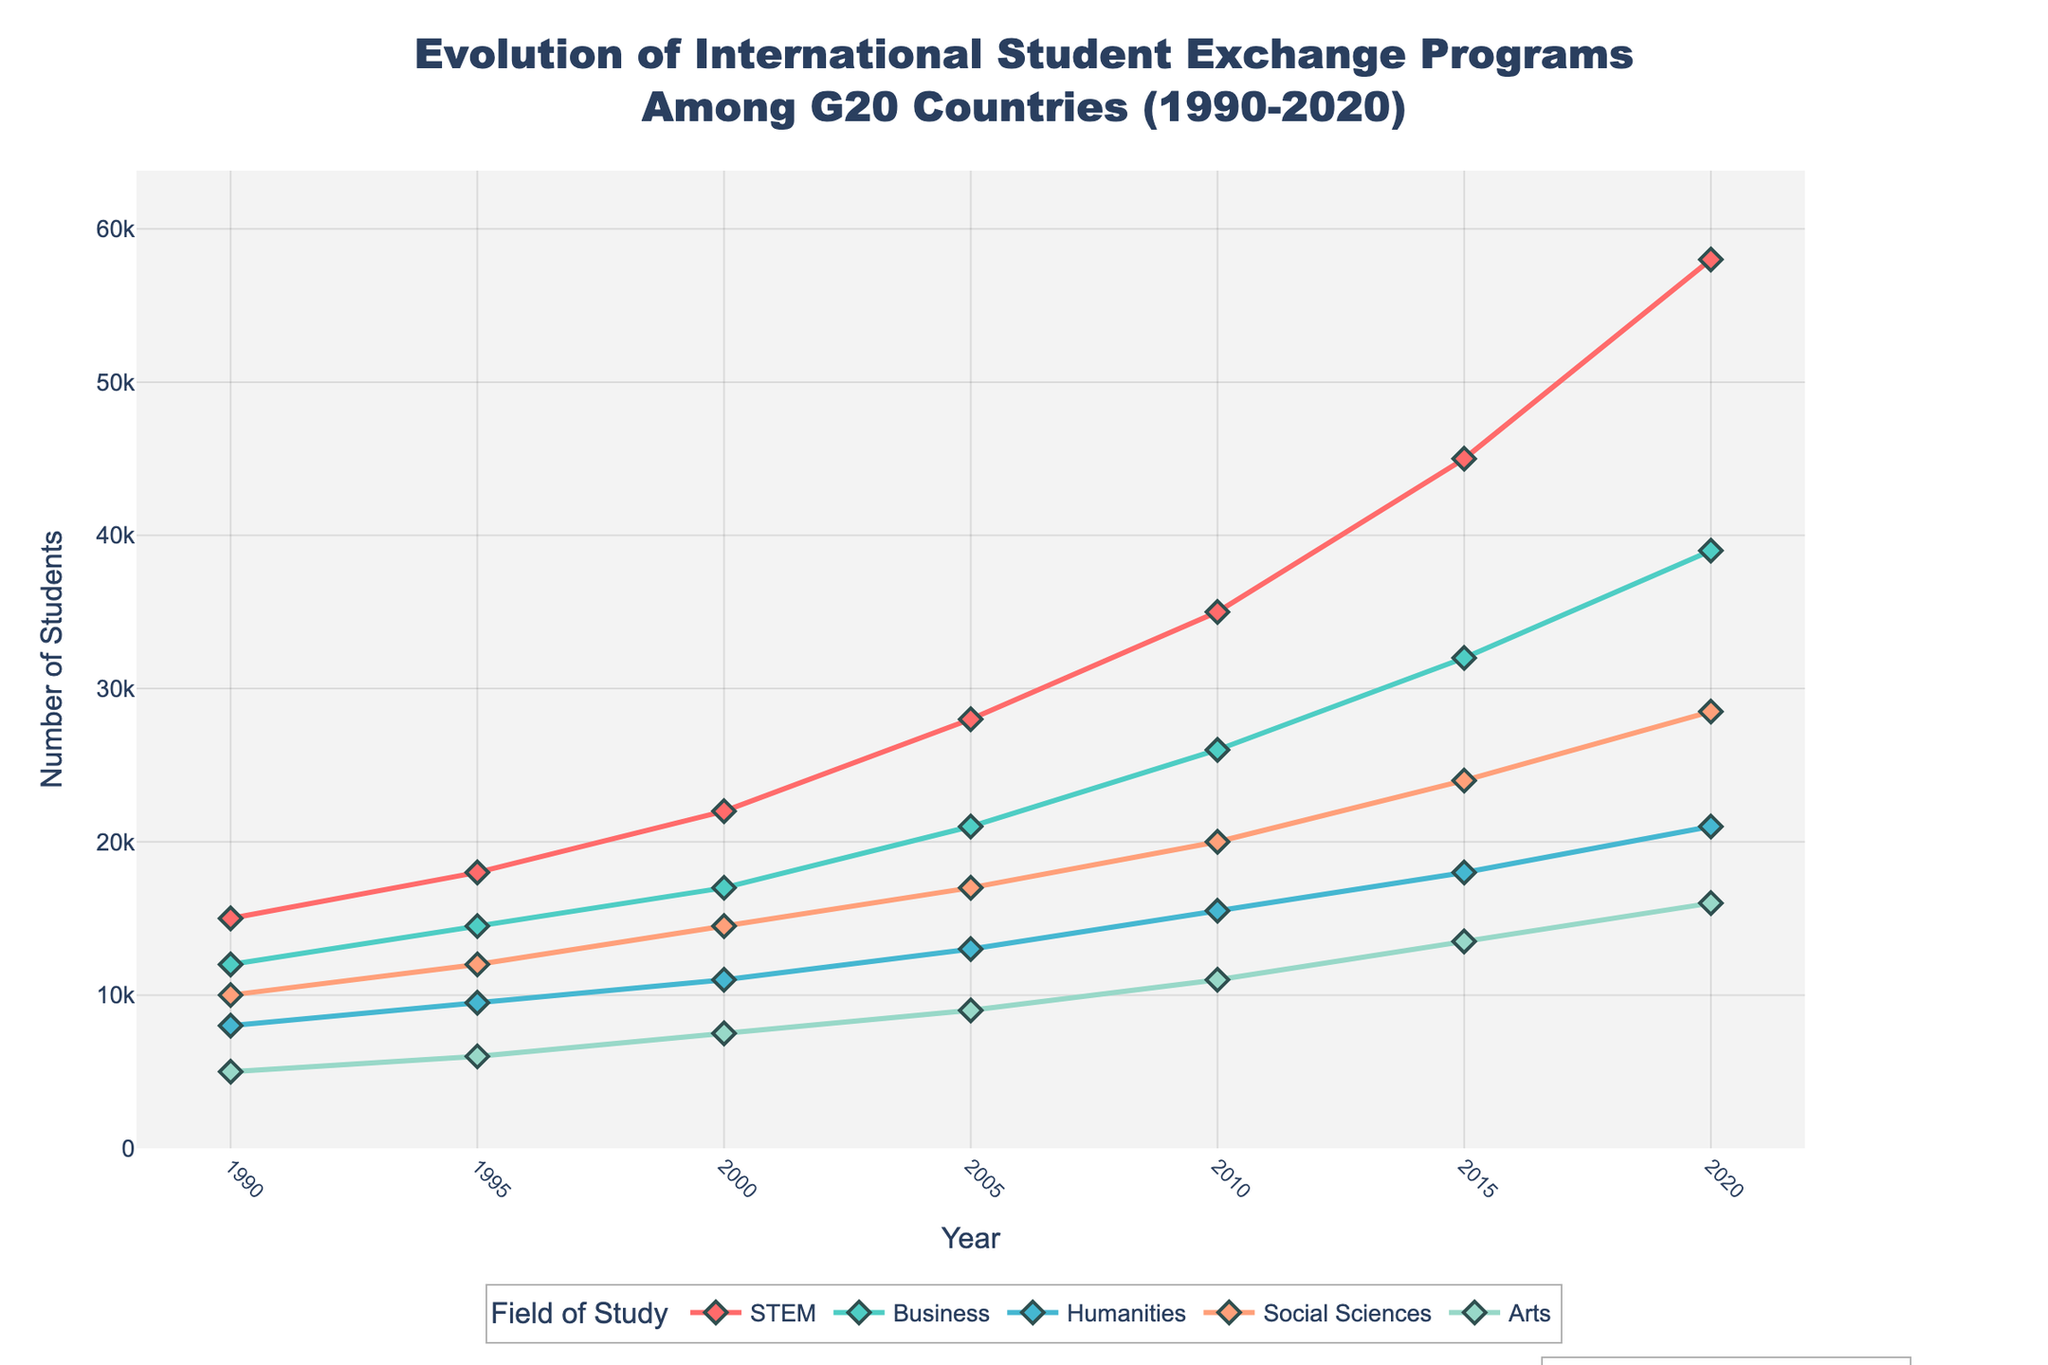What trend can you observe in the number of international students in STEM fields from 1990 to 2020? From 1990 to 2020, the number of international students in STEM fields consistently increases. Starting from 15,000 in 1990, the number rises to 58,000 by 2020. This growth illustrates a steady and significant rise over the 30-year period.
Answer: Increasing Which field of study had the most significant growth from 1990 to 2020? We calculate the growth for each field by subtracting the 1990 value from the 2020 value: 
STEM: 58,000 - 15,000 = 43,000
Business: 39,000 - 12,000 = 27,000
Humanities: 21,000 - 8,000 = 13,000
Social Sciences: 28,500 - 10,000 = 18,500
Arts: 16,000 - 5,000 = 11,000
STEM had the most significant growth with an increase of 43,000 students.
Answer: STEM In what year did the number of students in Business fields surpass 30,000? By examining the Business line in the chart, we observe that it surpasses 30,000 in the year 2015, reaching 32,000 students.
Answer: 2015 How does the number of students in the Arts field in 2020 compare to 1990? Comparing the values directly from the chart: 
1990: 5,000 students
2020: 16,000 students
The number of students in the Arts field in 2020 is 11,000 more than it was in 1990.
Answer: 11,000 more What is the average number of Social Sciences students over the years 1990 to 2020? We first obtain the sum of Social Sciences students for all years:
10,000 + 12,000 + 14,500 + 17,000 + 20,000 + 24,000 + 28,500 = 126,000
Then, divide by the number of years (7):
126,000 / 7 = 18,000
So, the average number of Social Sciences students is 18,000.
Answer: 18,000 Which field of study had the highest number of students in the year 2000? Referring to the numbers in 2000, we compare:
STEM: 22,000
Business: 17,000
Humanities: 11,000
Social Sciences: 14,500
Arts: 7,500
STEM had the highest number of students with 22,000.
Answer: STEM By how much did the number of Humanities students increase from 1995 to 2015? Calculate the difference between the 2015 and 1995 values:
2015: 18,000
1995: 9,500
The increase is 18,000 - 9,500 = 8,500 students.
Answer: 8,500 Between which two consecutive time points did the Business field see the largest increase in student numbers? To find the largest increase, we compute the differences between consecutive years:
1990-1995: 14,500 - 12,000 = 2,500
1995-2000: 17,000 - 14,500 = 2,500
2000-2005: 21,000 - 17,000 = 4,000
2005-2010: 26,000 - 21,000 = 5,000
2010-2015: 32,000 - 26,000 = 6,000
2015-2020: 39,000 - 32,000 = 7,000
The largest increase of 7,000 students occurred between 2015 and 2020.
Answer: 2015-2020 